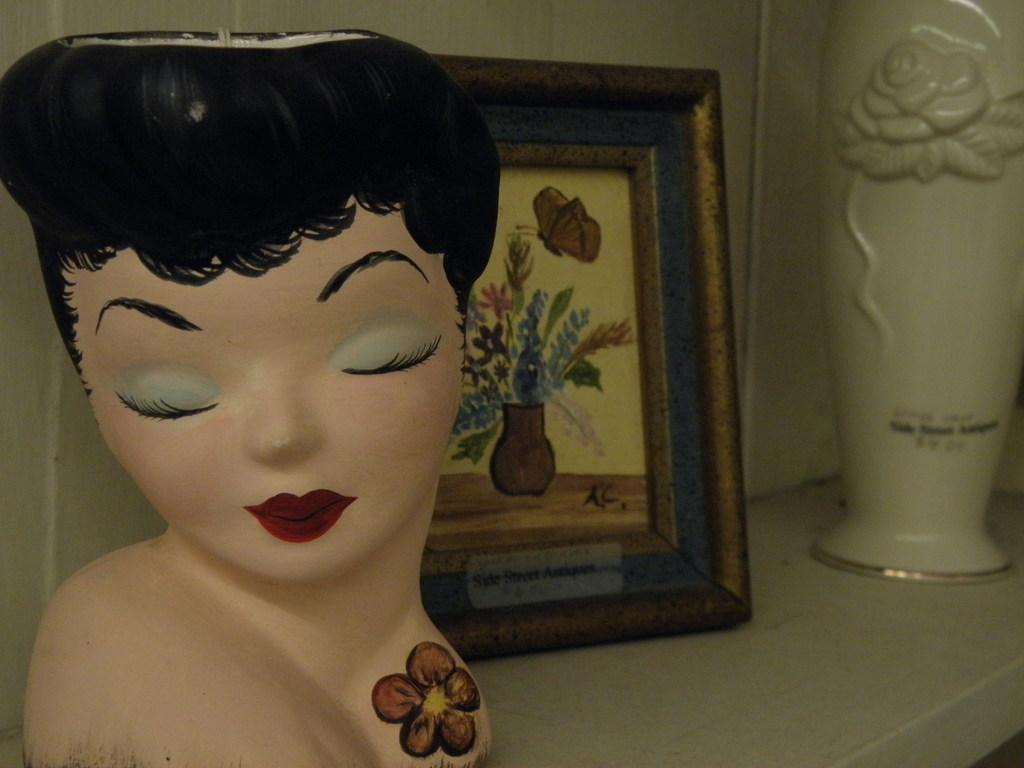What is the main subject of the image? There is a depiction of a lady in the center of the image. Are there any objects surrounding the lady? Yes, there is a photo frame and a flower vase in the image. What type of furniture is visible in the image? There is no furniture visible in the image; it only features a depiction of a lady, a photo frame, and a flower vase. 